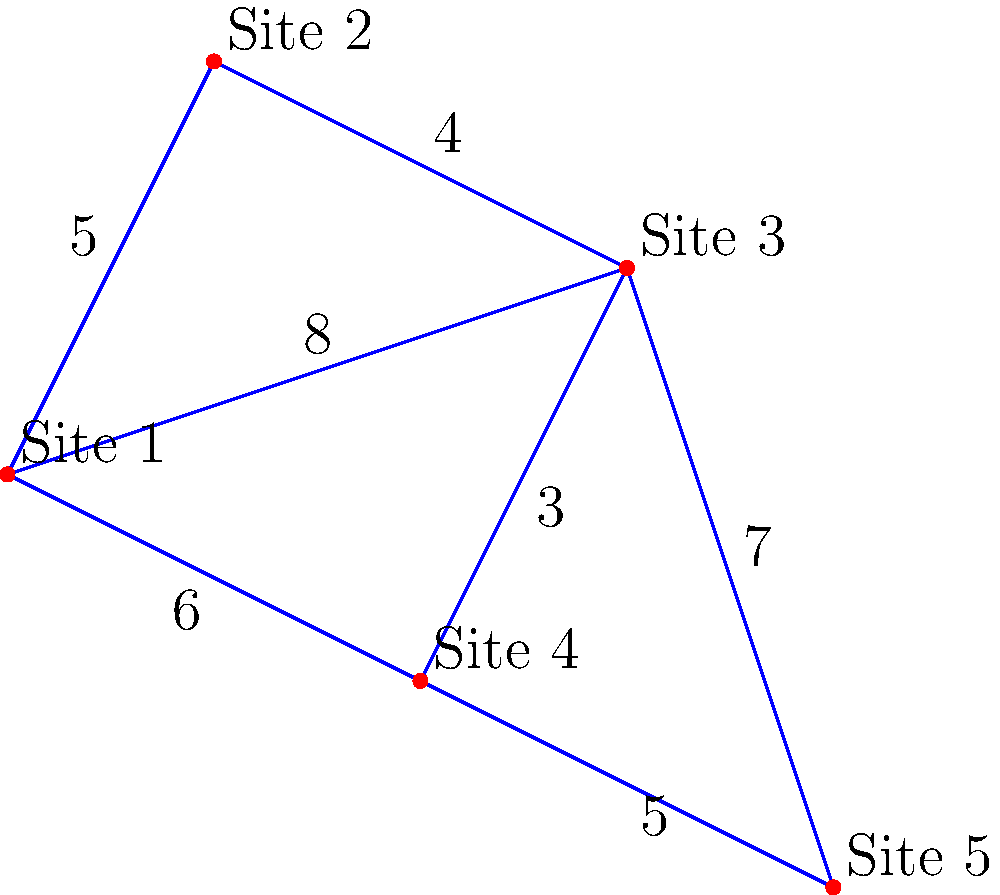You are tasked with connecting five historical sites for a restoration project. The diagram shows the possible connections between sites and their associated costs (in millions of dollars). What is the minimum total cost to connect all sites while ensuring that there is a path between any two sites? To solve this problem, we need to find the Minimum Spanning Tree (MST) of the given graph. We can use Kruskal's algorithm:

1. Sort all edges by weight (cost) in ascending order:
   (2,3): 3
   (1,2): 4
   (1,0): 5
   (3,4): 5
   (0,3): 6
   (2,4): 7
   (0,2): 8

2. Start with an empty set of edges and add edges one by one:
   a. Add (2,3): 3
   b. Add (1,2): 4
   c. Add (1,0): 5 (connects all vertices except 4)
   d. Add (3,4): 5 (connects the last vertex)

3. We stop here as we have connected all 5 vertices with 4 edges.

4. Calculate the total cost:
   $$3 + 4 + 5 + 5 = 17$$

Therefore, the minimum total cost to connect all sites is $17 million.
Answer: $17 million 